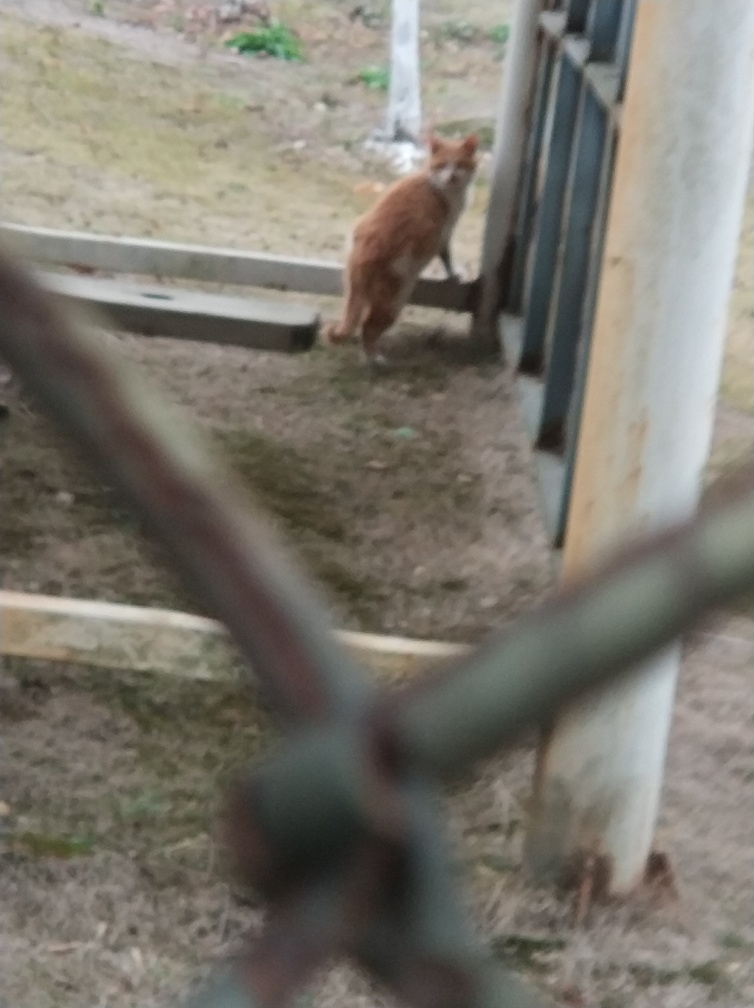What can you infer about the setting or environment based on this image? The setting seems to be an outdoor area with grass and some sparse vegetation. The presence of the cat and the man-made structures suggest this could be a residential or semi-urban environment. 